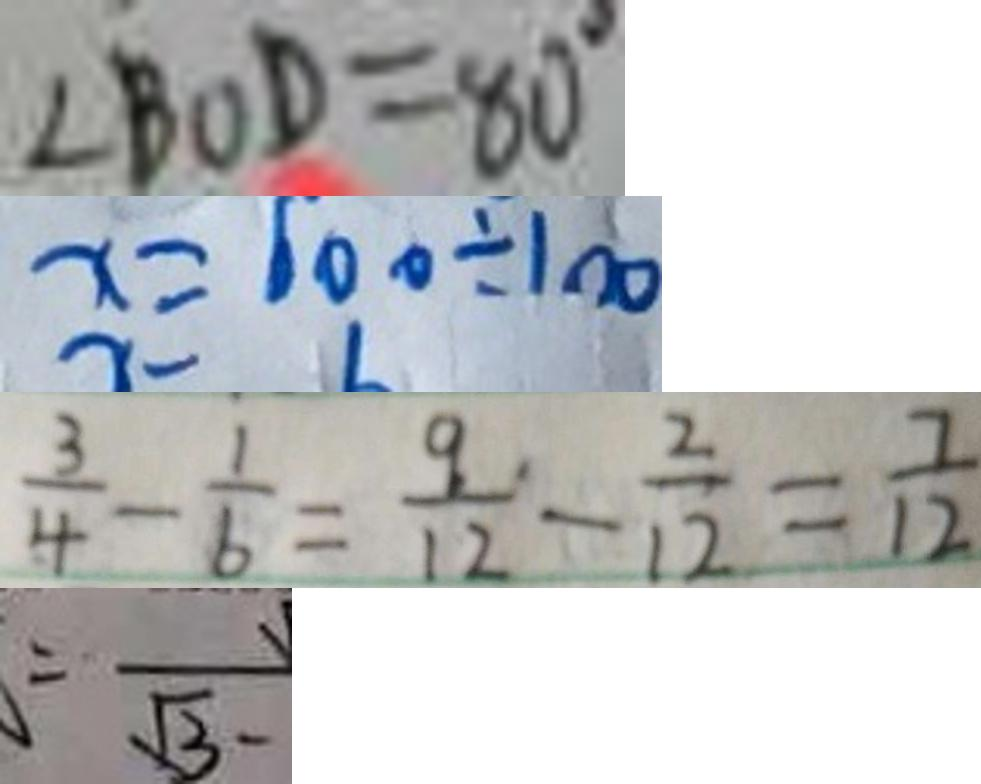Convert formula to latex. <formula><loc_0><loc_0><loc_500><loc_500>\angle B O D = 8 0 ^ { \circ } 
 x = 6 0 0 \div 1 0 0 
 \frac { 3 } { 4 } - \frac { 1 } { 6 } = \frac { 9 } { 1 2 } - \frac { 2 } { 1 2 } = \frac { 7 } { 1 2 } 
 = \overrightarrow { \sqrt { 3 } }</formula> 